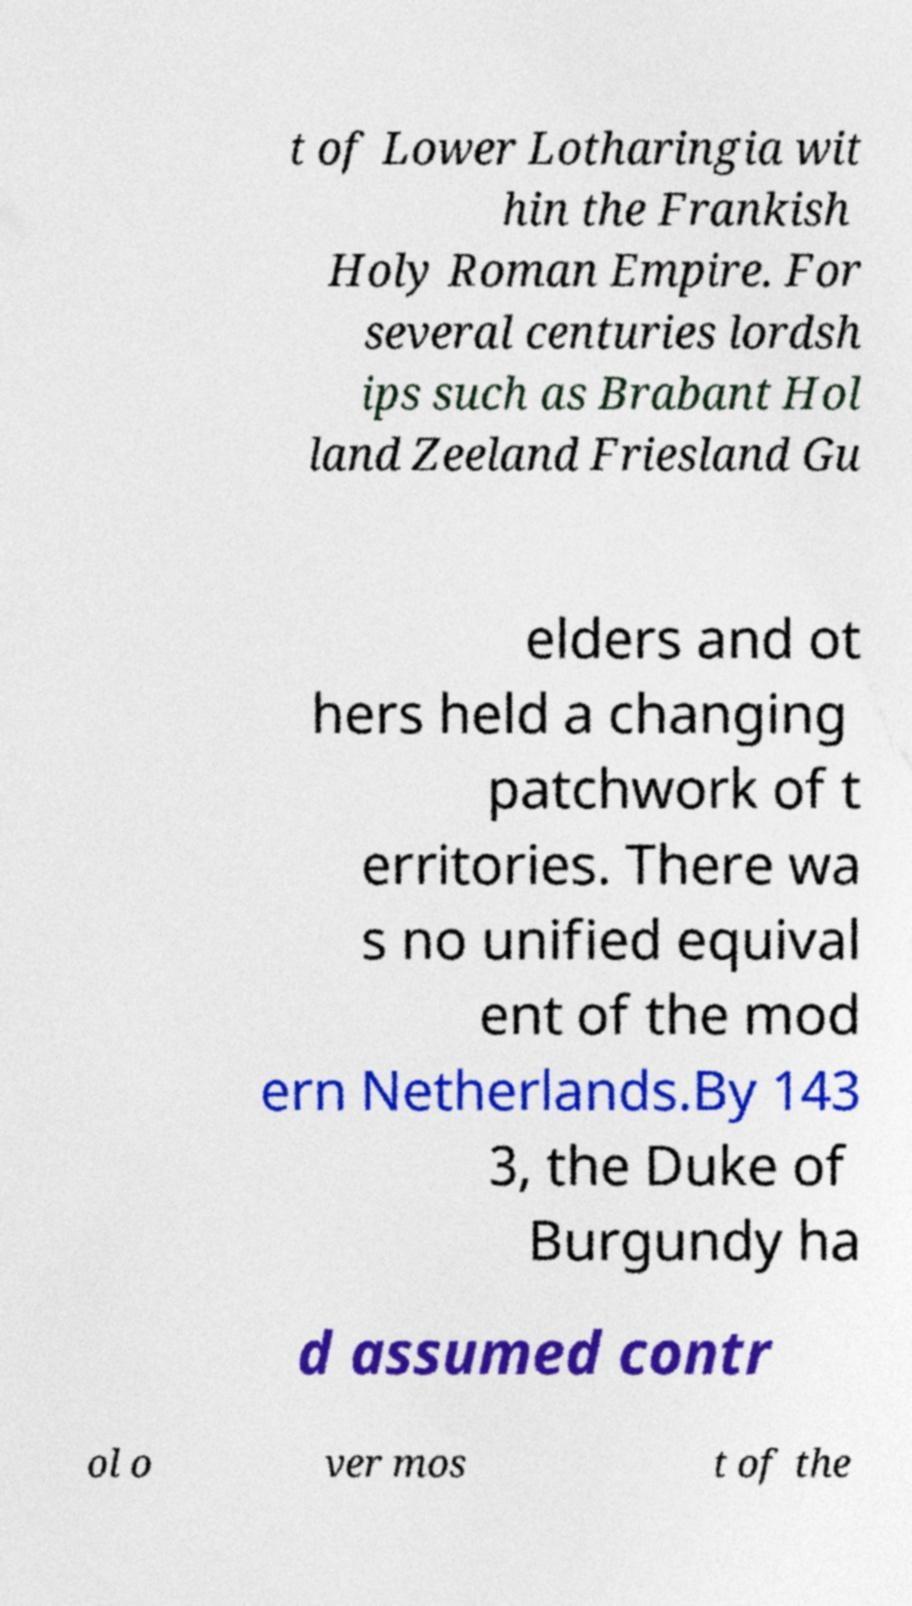Please read and relay the text visible in this image. What does it say? t of Lower Lotharingia wit hin the Frankish Holy Roman Empire. For several centuries lordsh ips such as Brabant Hol land Zeeland Friesland Gu elders and ot hers held a changing patchwork of t erritories. There wa s no unified equival ent of the mod ern Netherlands.By 143 3, the Duke of Burgundy ha d assumed contr ol o ver mos t of the 